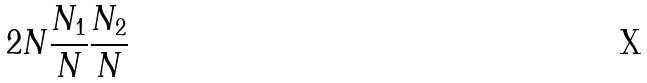Convert formula to latex. <formula><loc_0><loc_0><loc_500><loc_500>2 N \frac { N _ { 1 } } { N } \frac { N _ { 2 } } { N }</formula> 